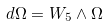Convert formula to latex. <formula><loc_0><loc_0><loc_500><loc_500>d \Omega = W _ { 5 } \wedge \Omega</formula> 